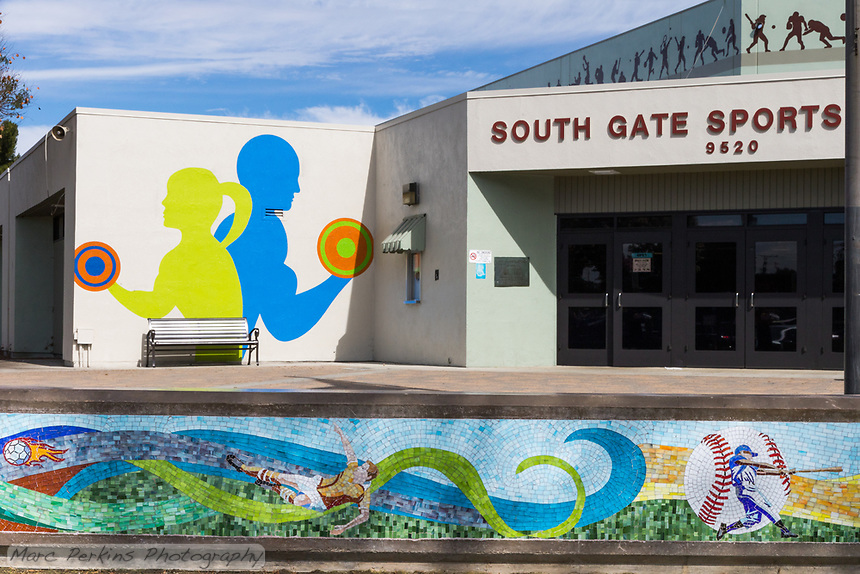What is the significance of the artistic style used in the murals at this facility? The modern and abstract artistic style used in the murals of the South Gate Sports facility enhances its visual appeal and captures the dynamic nature of sports. This style may also resonate well with a diverse audience, especially the younger demographic, encouraging them to engage more with the sports activities offered. These artistic choices help communicate a sense of energy and movement, which is intrinsic to sports, making the facility both a sports center and a local landmark. 